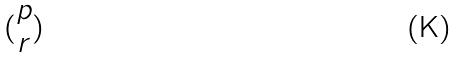<formula> <loc_0><loc_0><loc_500><loc_500>( \begin{matrix} p \\ r \end{matrix} )</formula> 